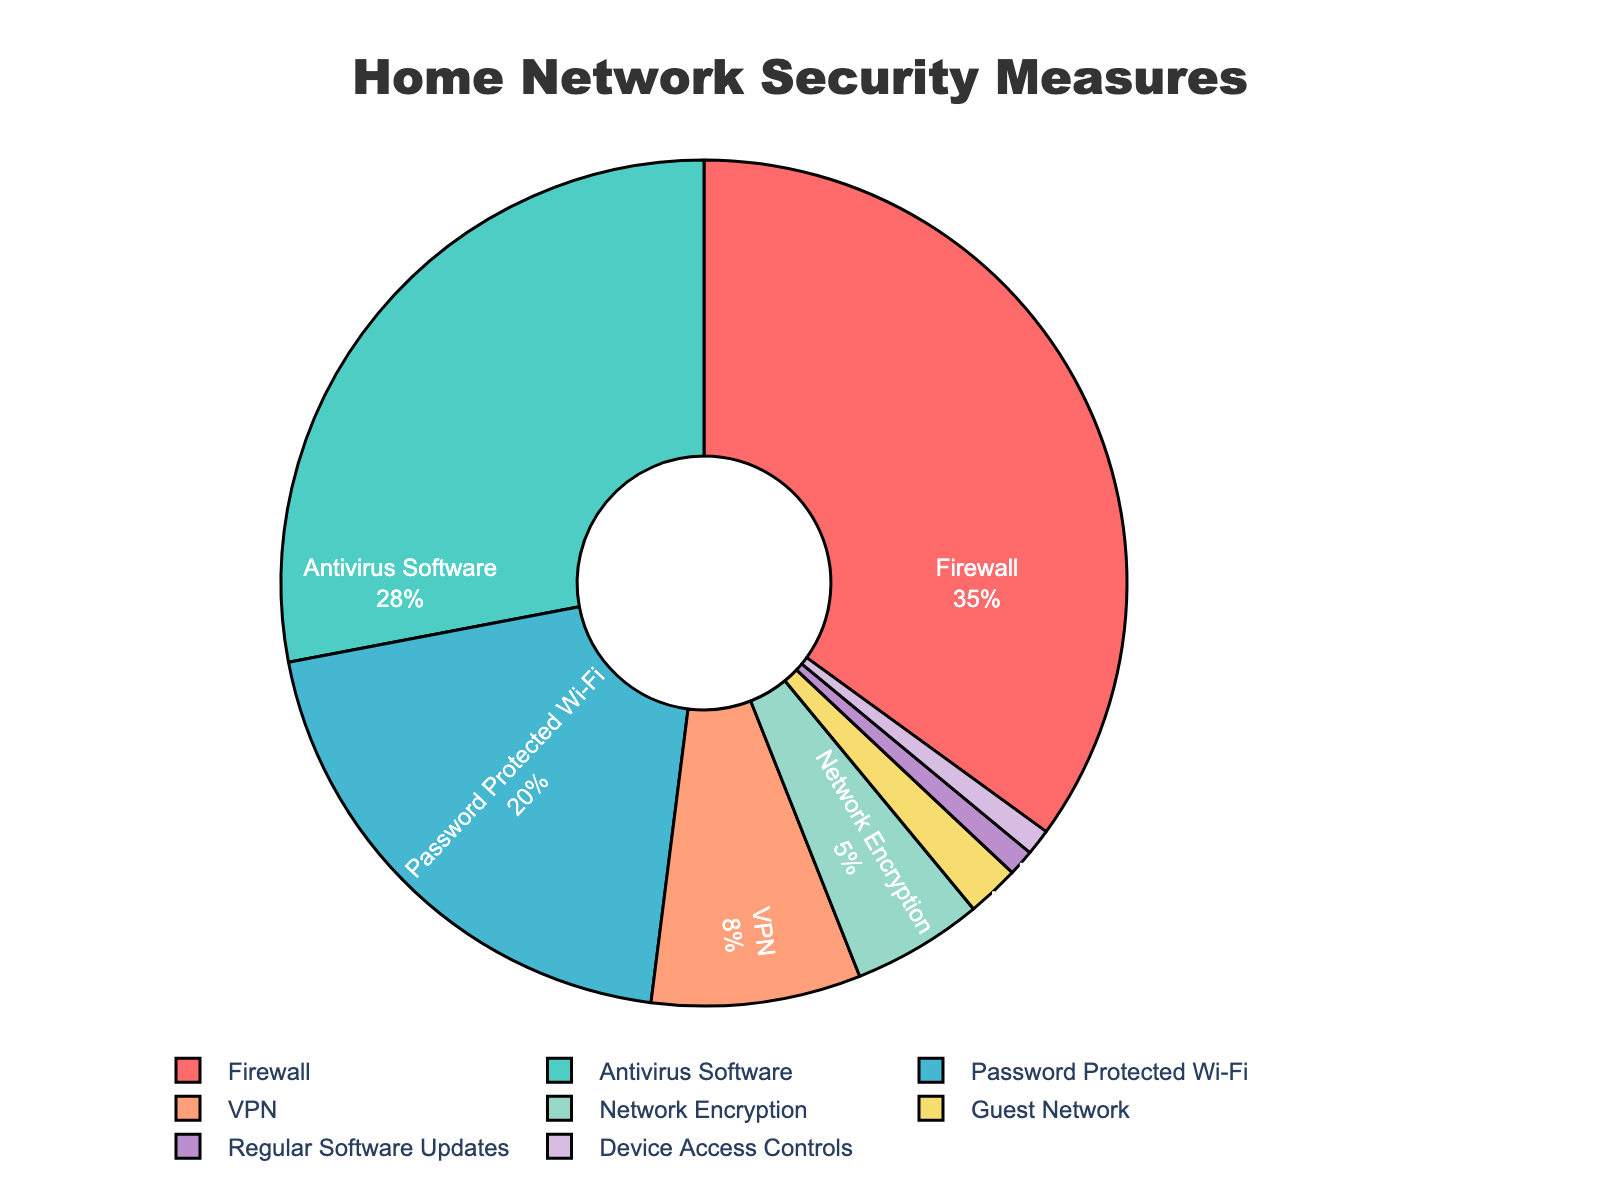Which security measure has the highest percentage of implementation? The figure shows a pie chart with different slices representing various security measures. The largest slice is labeled "Firewall," and its associated percentage is 35%.
Answer: Firewall What is the combined percentage of Antivirus Software and Password Protected Wi-Fi? To find the combined percentage, add the percentages of Antivirus Software (28%) and Password Protected Wi-Fi (20%). 28% + 20% = 48%
Answer: 48% How much more prevalent is the Firewall than the VPN? To determine how much more prevalent the Firewall is compared to the VPN, subtract the VPN percentage (8%) from the Firewall percentage (35%). 35% - 8% = 27%
Answer: 27% Which security measures are implemented less than 5% of the time? By examining the pie chart, security measures with less than 5% implementation include Network Encryption (5%), Guest Network (2%), Regular Software Updates (1%), and Device Access Controls (1%).
Answer: Network Encryption, Guest Network, Regular Software Updates, Device Access Controls Are there any security measures that have the same percentage of implementation? The pie chart shows that both Regular Software Updates and Device Access Controls have a percentage of 1%.
Answer: Regular Software Updates and Device Access Controls What is the total percentage of security measures implemented in the 'VPN', 'Network Encryption', and 'Guest Network' combined? Add the percentages of VPN (8%), Network Encryption (5%), and Guest Network (2%). 8% + 5% + 2% = 15%
Answer: 15% Which security measure is the least implemented? The figure shows a slice labeled "Device Access Controls" with the smallest percentage of 1%.
Answer: Device Access Controls Does Firewall and Antivirus Software combined cover more than 50% of the security measures? To determine this, add the percentages of Firewall (35%) and Antivirus Software (28%). The sum is 35% + 28% = 63%, which is more than 50%.
Answer: Yes What is the difference in implementation percentage between Password Protected Wi-Fi and Network Encryption? Subtract the percentage of Network Encryption (5%) from Password Protected Wi-Fi (20%). 20% - 5% = 15%
Answer: 15% Identify the measure represented by the orange slice. The pie chart uses colors to visually differentiate segments, and the orange slice is labeled "VPN."
Answer: VPN 